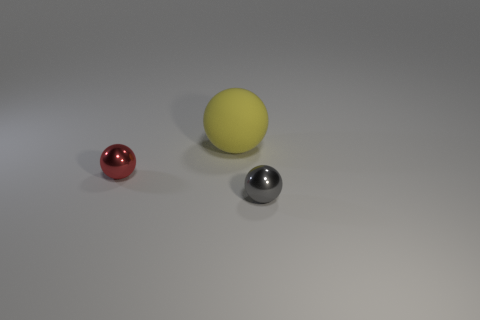There is a small metallic sphere behind the gray object; what is its color?
Offer a terse response. Red. There is a object that is both on the right side of the red metallic thing and in front of the rubber ball; what shape is it?
Your response must be concise. Sphere. How many small gray things are the same shape as the red object?
Offer a very short reply. 1. How many big yellow balls are there?
Make the answer very short. 1. How big is the ball that is both in front of the large yellow object and to the right of the tiny red object?
Ensure brevity in your answer.  Small. What is the shape of the gray shiny object that is the same size as the red shiny ball?
Provide a short and direct response. Sphere. There is a shiny ball that is in front of the red shiny ball; are there any spheres in front of it?
Offer a terse response. No. There is a rubber thing that is the same shape as the tiny red metallic thing; what is its color?
Make the answer very short. Yellow. There is a shiny object that is in front of the red ball; is its color the same as the rubber sphere?
Offer a very short reply. No. How many objects are either gray shiny balls that are in front of the large yellow rubber object or tiny green shiny balls?
Your answer should be very brief. 1. 